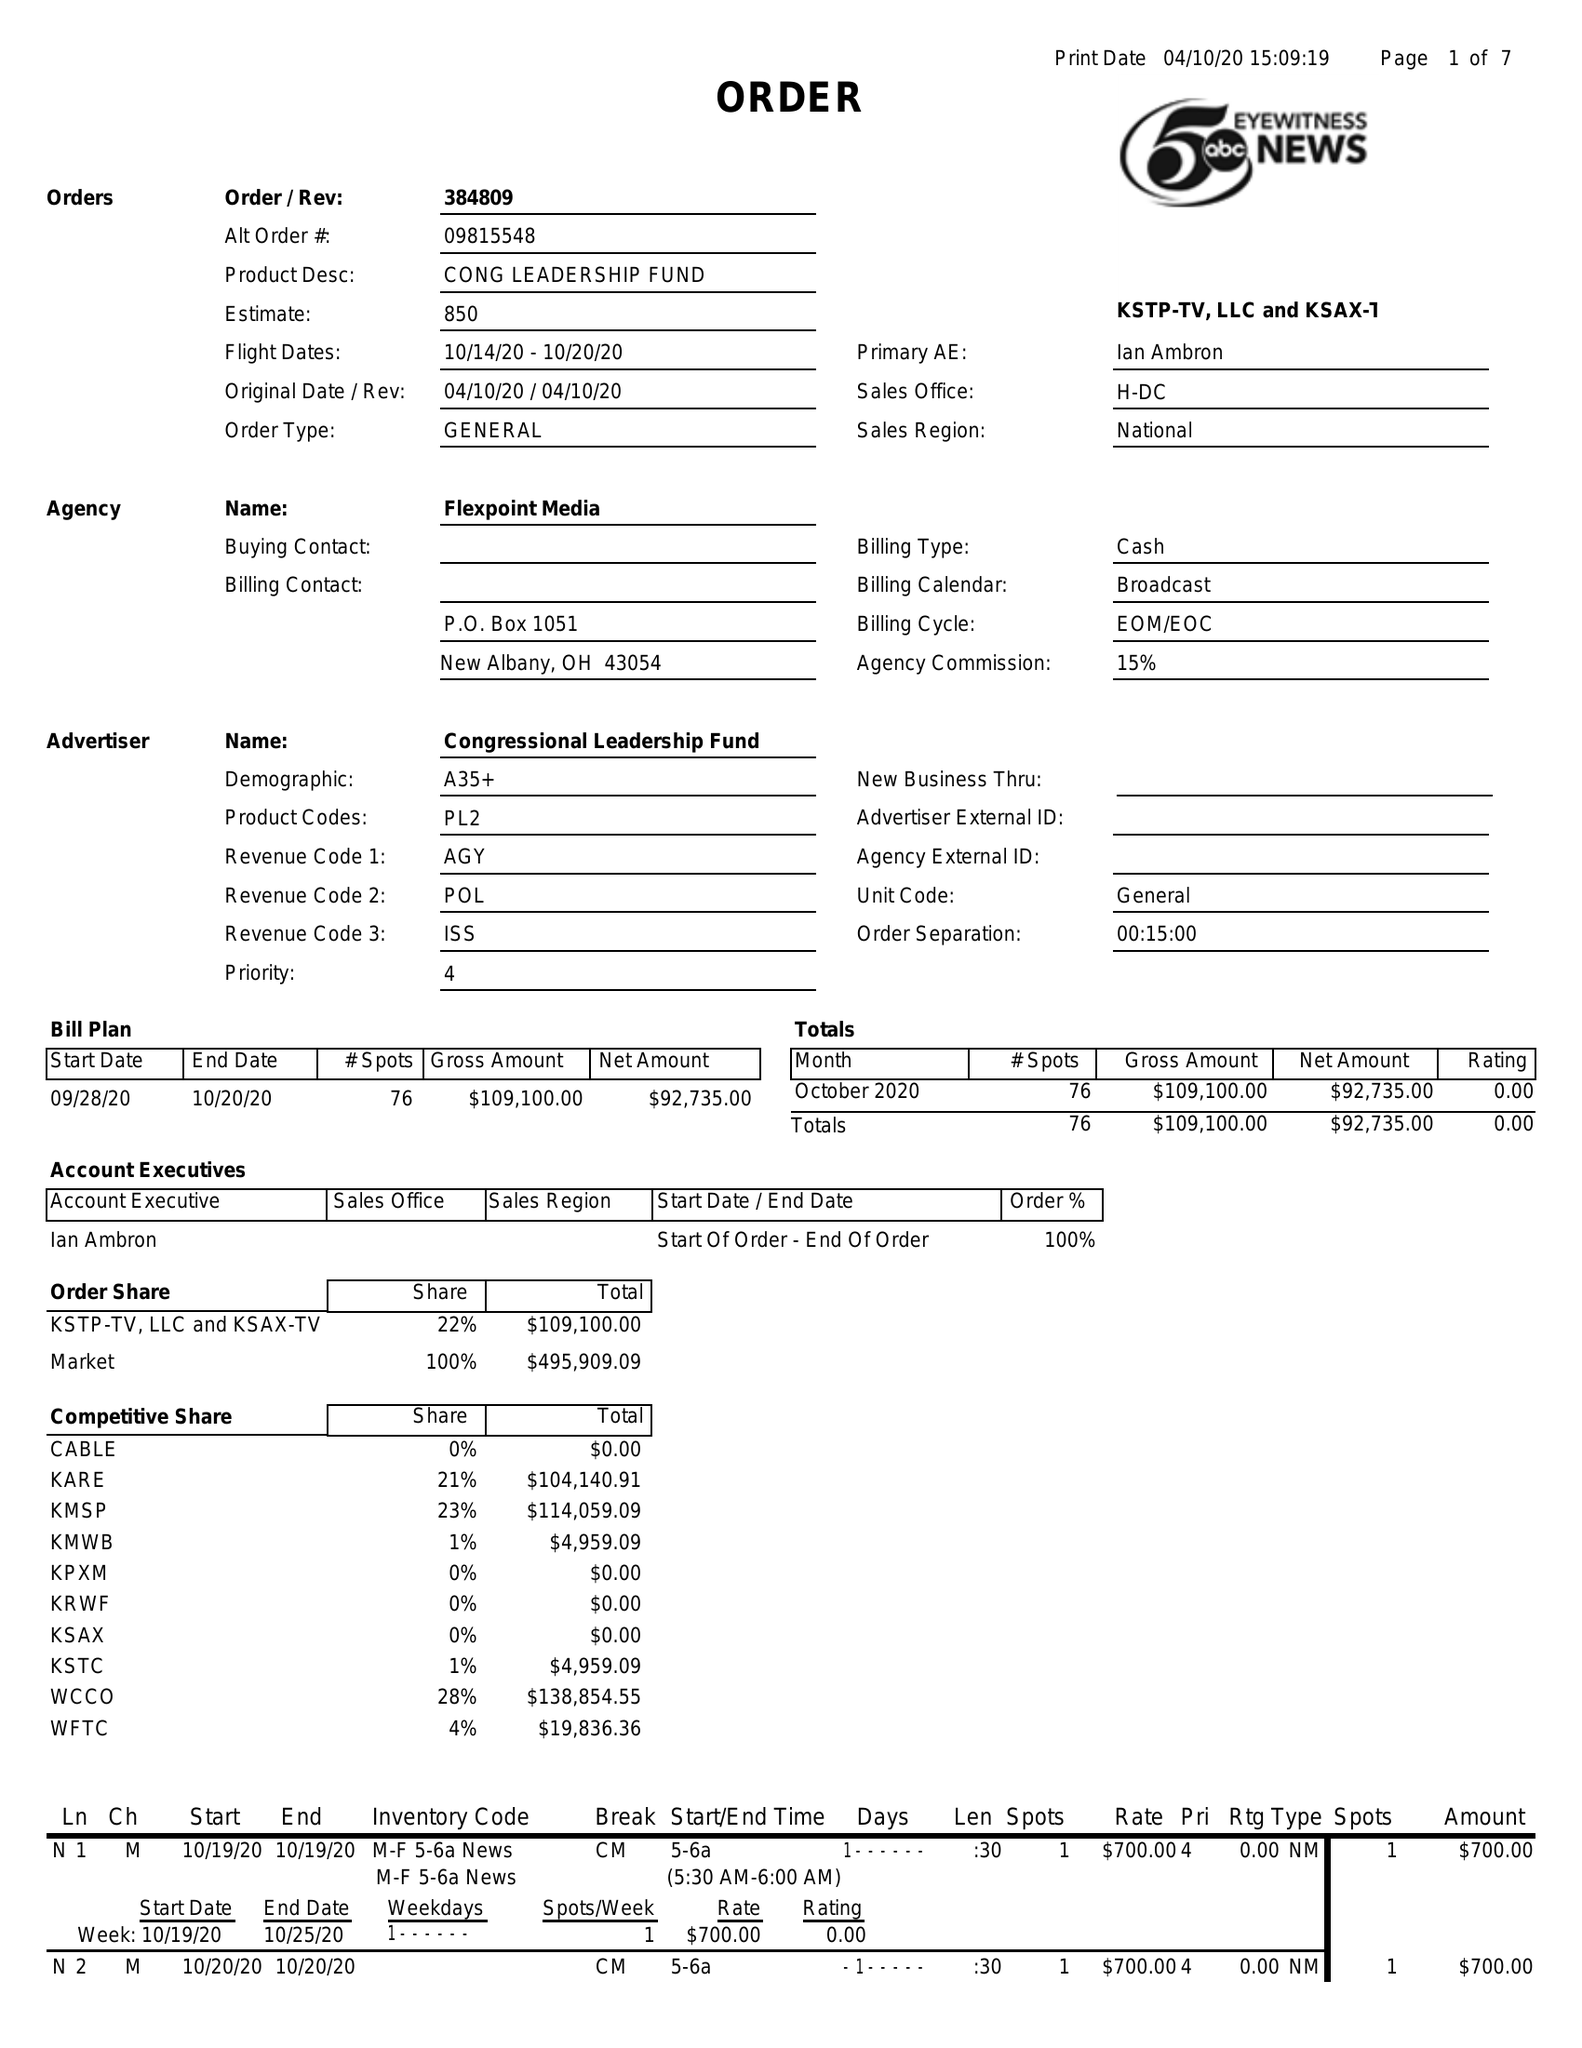What is the value for the contract_num?
Answer the question using a single word or phrase. 384809 